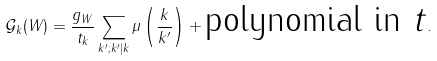<formula> <loc_0><loc_0><loc_500><loc_500>{ \mathcal { G } } _ { k } ( W ) = \frac { g _ { W } } { t _ { k } } \sum _ { k ^ { \prime } ; k ^ { \prime } | k } \mu \left ( \frac { k } { k ^ { \prime } } \right ) + \text {polynomial in $t$} .</formula> 